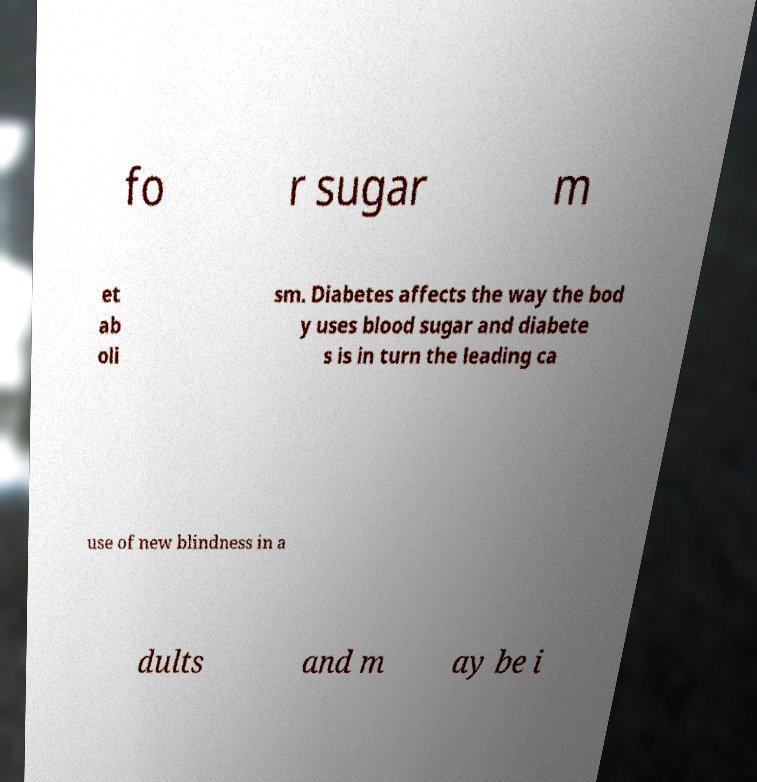Can you read and provide the text displayed in the image?This photo seems to have some interesting text. Can you extract and type it out for me? fo r sugar m et ab oli sm. Diabetes affects the way the bod y uses blood sugar and diabete s is in turn the leading ca use of new blindness in a dults and m ay be i 